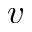<formula> <loc_0><loc_0><loc_500><loc_500>v</formula> 